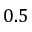Convert formula to latex. <formula><loc_0><loc_0><loc_500><loc_500>0 . 5</formula> 